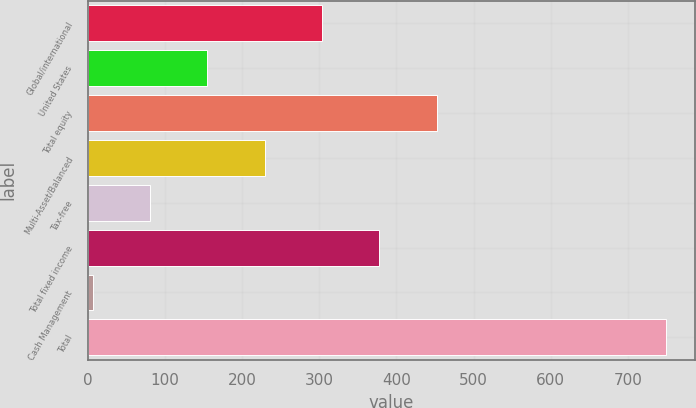<chart> <loc_0><loc_0><loc_500><loc_500><bar_chart><fcel>Global/international<fcel>United States<fcel>Total equity<fcel>Multi-Asset/Balanced<fcel>Tax-free<fcel>Total fixed income<fcel>Cash Management<fcel>Total<nl><fcel>303.62<fcel>155.06<fcel>452.18<fcel>229.34<fcel>80.78<fcel>377.9<fcel>6.5<fcel>749.3<nl></chart> 